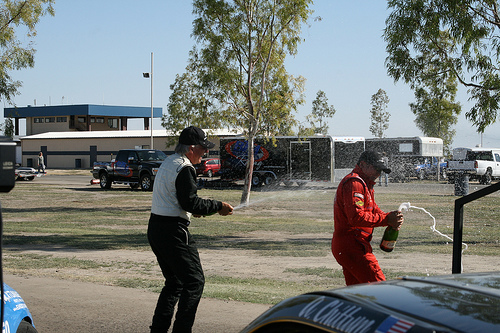<image>
Can you confirm if the white man is to the right of the red man? No. The white man is not to the right of the red man. The horizontal positioning shows a different relationship. 